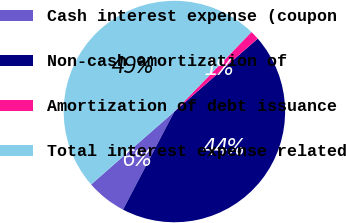Convert chart to OTSL. <chart><loc_0><loc_0><loc_500><loc_500><pie_chart><fcel>Cash interest expense (coupon<fcel>Non-cash amortization of<fcel>Amortization of debt issuance<fcel>Total interest expense related<nl><fcel>5.88%<fcel>44.12%<fcel>1.31%<fcel>48.69%<nl></chart> 